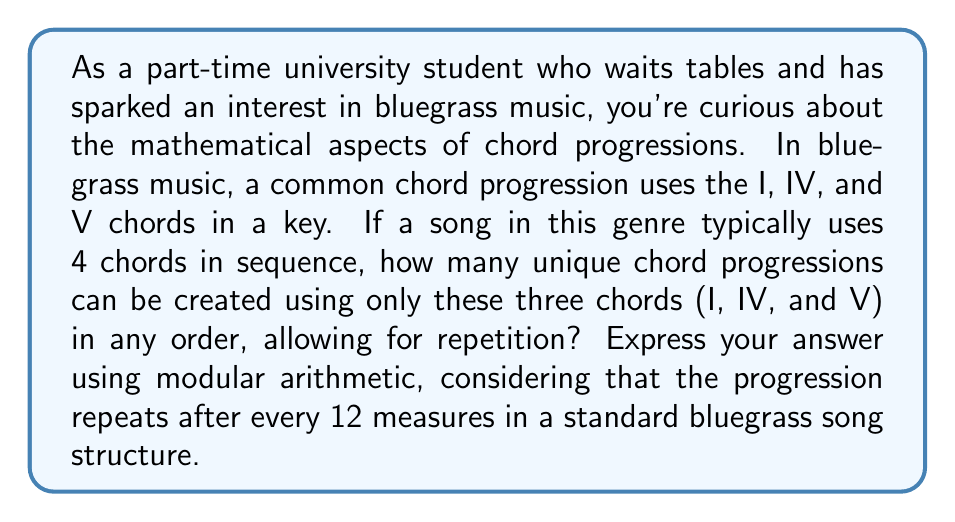Could you help me with this problem? Let's approach this step-by-step:

1) First, we need to understand what we're counting. We're looking at sequences of 4 chords, where each chord can be I, IV, or V.

2) This is a problem of counting with repetition allowed. For each of the 4 positions in the sequence, we have 3 choices.

3) The total number of possible sequences is therefore:

   $$3 \times 3 \times 3 \times 3 = 3^4 = 81$$

4) Now, we need to consider the modular arithmetic aspect. In a standard bluegrass song structure, the progression repeats every 12 measures.

5) This means we're interested in the number of unique progressions modulo 12.

6) To express this in modular arithmetic, we write:

   $$81 \equiv 9 \pmod{12}$$

7) This is because 81 divided by 12 gives a remainder of 9:

   $$81 = 6 \times 12 + 9$$

8) Therefore, in terms of creating unique-sounding progressions within the 12-measure structure, there are effectively 9 distinct possibilities.
Answer: $81 \equiv 9 \pmod{12}$ 